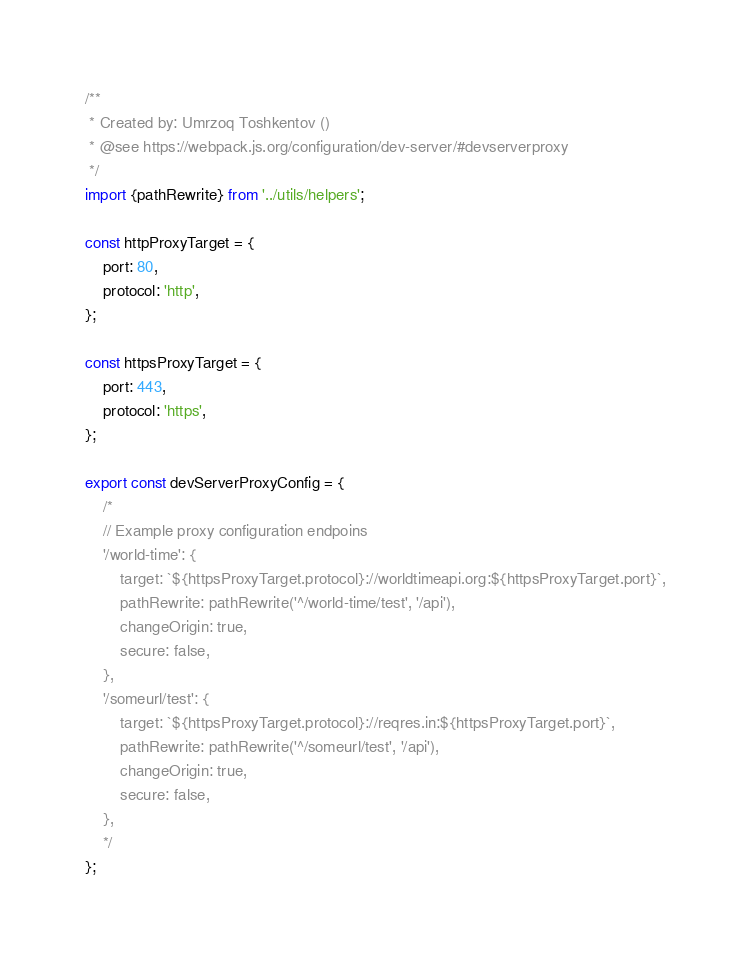Convert code to text. <code><loc_0><loc_0><loc_500><loc_500><_JavaScript_>/**
 * Created by: Umrzoq Toshkentov ()
 * @see https://webpack.js.org/configuration/dev-server/#devserverproxy
 */
import {pathRewrite} from '../utils/helpers';

const httpProxyTarget = {
    port: 80,
    protocol: 'http',
};

const httpsProxyTarget = {
    port: 443,
    protocol: 'https',
};

export const devServerProxyConfig = {
    /*
    // Example proxy configuration endpoins
    '/world-time': {
        target: `${httpsProxyTarget.protocol}://worldtimeapi.org:${httpsProxyTarget.port}`,
        pathRewrite: pathRewrite('^/world-time/test', '/api'),
        changeOrigin: true,
        secure: false,
    },
    '/someurl/test': {
        target: `${httpsProxyTarget.protocol}://reqres.in:${httpsProxyTarget.port}`,
        pathRewrite: pathRewrite('^/someurl/test', '/api'),
        changeOrigin: true,
        secure: false,
    },
    */
};
</code> 